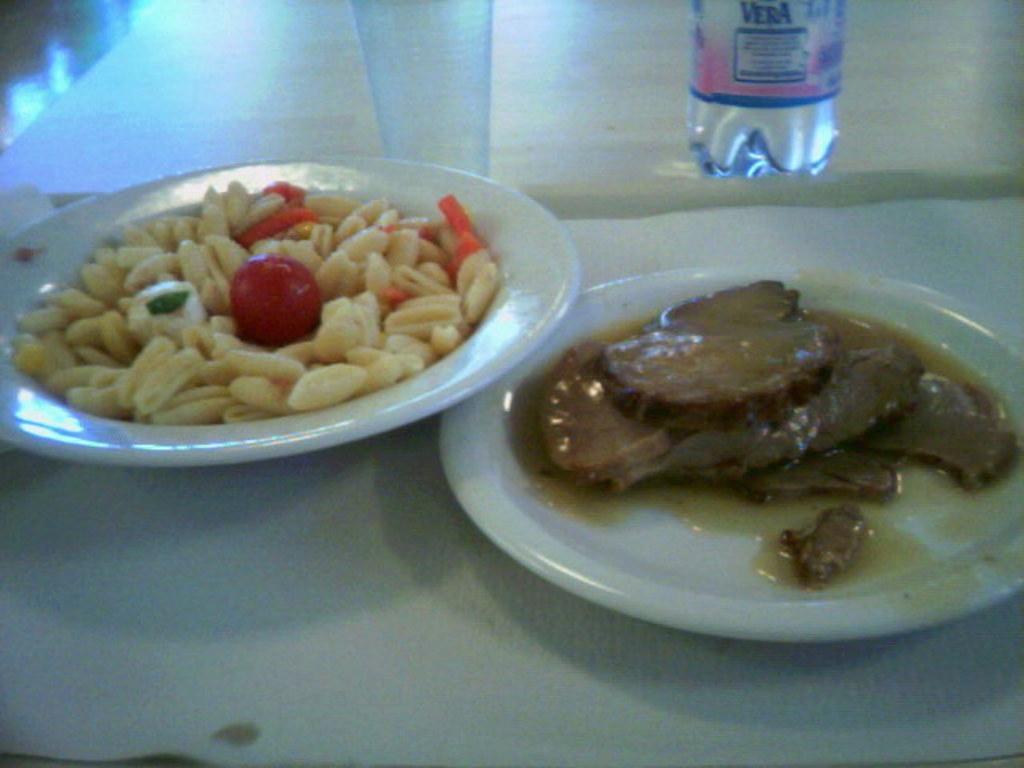How would you summarize this image in a sentence or two? In this picture I can see some food items are on the plate which is kept on the table, side we can see a bottle and glass. 